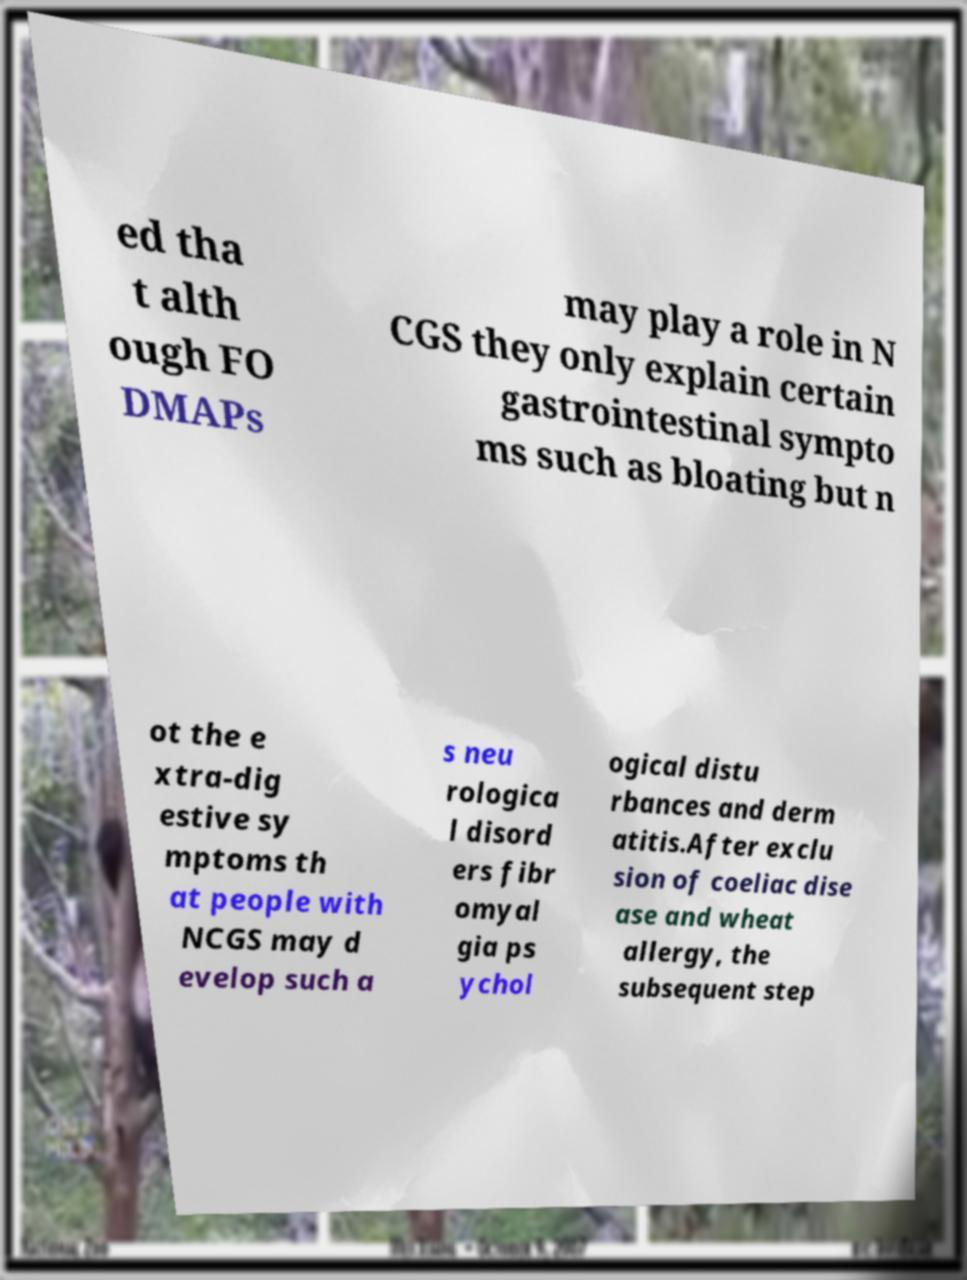Could you extract and type out the text from this image? ed tha t alth ough FO DMAPs may play a role in N CGS they only explain certain gastrointestinal sympto ms such as bloating but n ot the e xtra-dig estive sy mptoms th at people with NCGS may d evelop such a s neu rologica l disord ers fibr omyal gia ps ychol ogical distu rbances and derm atitis.After exclu sion of coeliac dise ase and wheat allergy, the subsequent step 